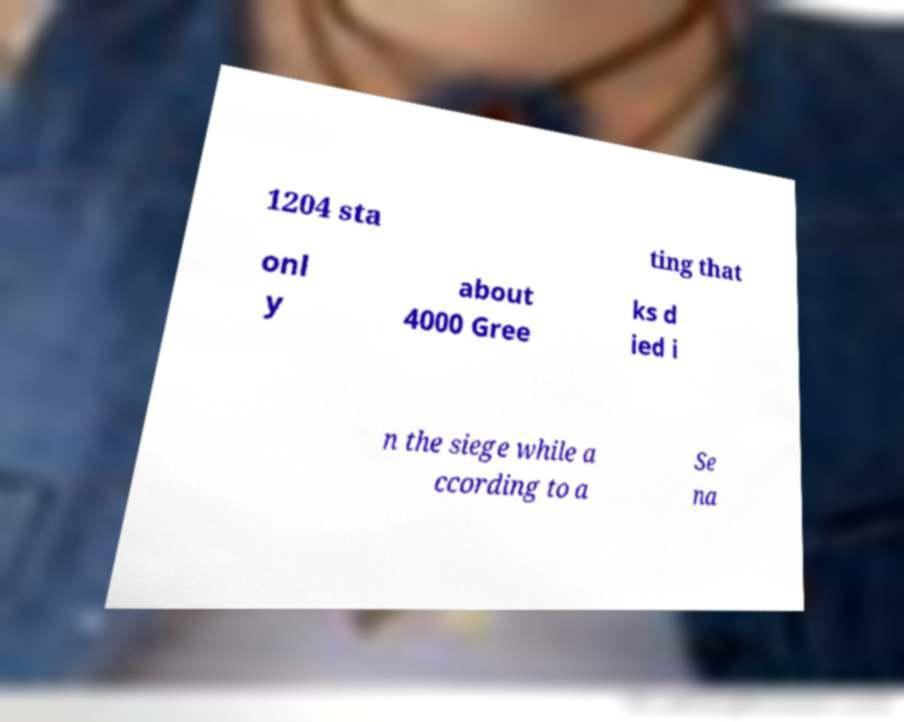For documentation purposes, I need the text within this image transcribed. Could you provide that? 1204 sta ting that onl y about 4000 Gree ks d ied i n the siege while a ccording to a Se na 